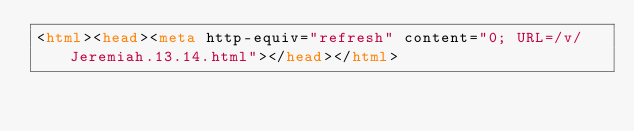Convert code to text. <code><loc_0><loc_0><loc_500><loc_500><_HTML_><html><head><meta http-equiv="refresh" content="0; URL=/v/Jeremiah.13.14.html"></head></html></code> 